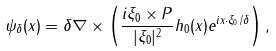<formula> <loc_0><loc_0><loc_500><loc_500>\psi _ { \delta } ( x ) = \delta \nabla \times \left ( \frac { i \xi _ { 0 } \times P } { | \xi _ { 0 } | ^ { 2 } } h _ { 0 } ( x ) e ^ { i x \cdot \xi _ { 0 } / \delta } \right ) ,</formula> 